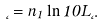<formula> <loc_0><loc_0><loc_500><loc_500>\hat { \Phi } = n _ { 1 } \ln 1 0 L \Phi .</formula> 